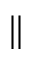Convert formula to latex. <formula><loc_0><loc_0><loc_500><loc_500>\|</formula> 